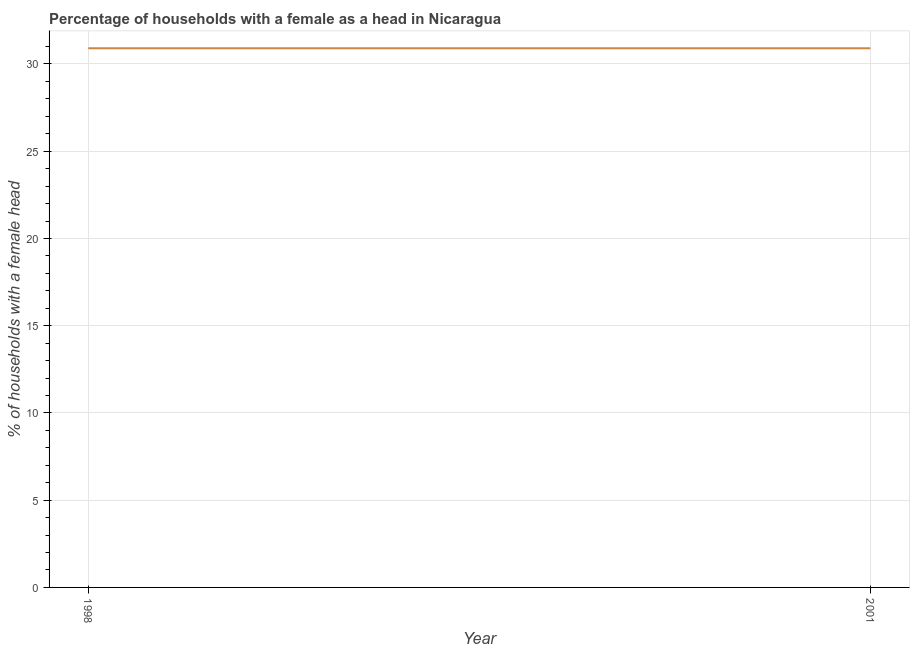What is the number of female supervised households in 2001?
Your response must be concise. 30.9. Across all years, what is the maximum number of female supervised households?
Keep it short and to the point. 30.9. Across all years, what is the minimum number of female supervised households?
Your answer should be very brief. 30.9. What is the sum of the number of female supervised households?
Ensure brevity in your answer.  61.8. What is the average number of female supervised households per year?
Keep it short and to the point. 30.9. What is the median number of female supervised households?
Offer a very short reply. 30.9. What is the ratio of the number of female supervised households in 1998 to that in 2001?
Make the answer very short. 1. Does the number of female supervised households monotonically increase over the years?
Make the answer very short. No. How many years are there in the graph?
Make the answer very short. 2. What is the difference between two consecutive major ticks on the Y-axis?
Offer a very short reply. 5. Are the values on the major ticks of Y-axis written in scientific E-notation?
Your response must be concise. No. Does the graph contain grids?
Your answer should be compact. Yes. What is the title of the graph?
Keep it short and to the point. Percentage of households with a female as a head in Nicaragua. What is the label or title of the X-axis?
Your response must be concise. Year. What is the label or title of the Y-axis?
Offer a very short reply. % of households with a female head. What is the % of households with a female head in 1998?
Ensure brevity in your answer.  30.9. What is the % of households with a female head in 2001?
Give a very brief answer. 30.9. What is the difference between the % of households with a female head in 1998 and 2001?
Offer a very short reply. 0. 